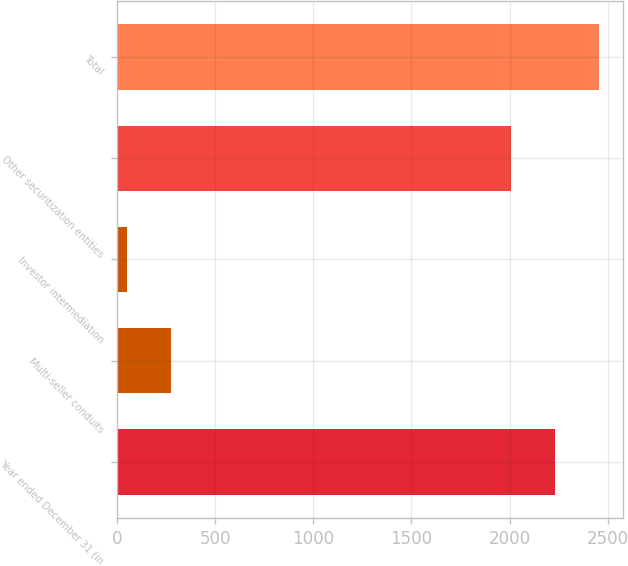Convert chart to OTSL. <chart><loc_0><loc_0><loc_500><loc_500><bar_chart><fcel>Year ended December 31 (in<fcel>Multi-seller conduits<fcel>Investor intermediation<fcel>Other securitization entities<fcel>Total<nl><fcel>2229.5<fcel>273.5<fcel>49<fcel>2005<fcel>2454<nl></chart> 